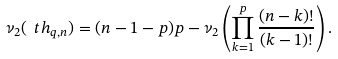Convert formula to latex. <formula><loc_0><loc_0><loc_500><loc_500>\nu _ { 2 } ( \ t h _ { q , n } ) = ( n - 1 - p ) p - \nu _ { 2 } \left ( \prod _ { k = 1 } ^ { p } \frac { ( n - k ) ! } { ( k - 1 ) ! } \right ) .</formula> 